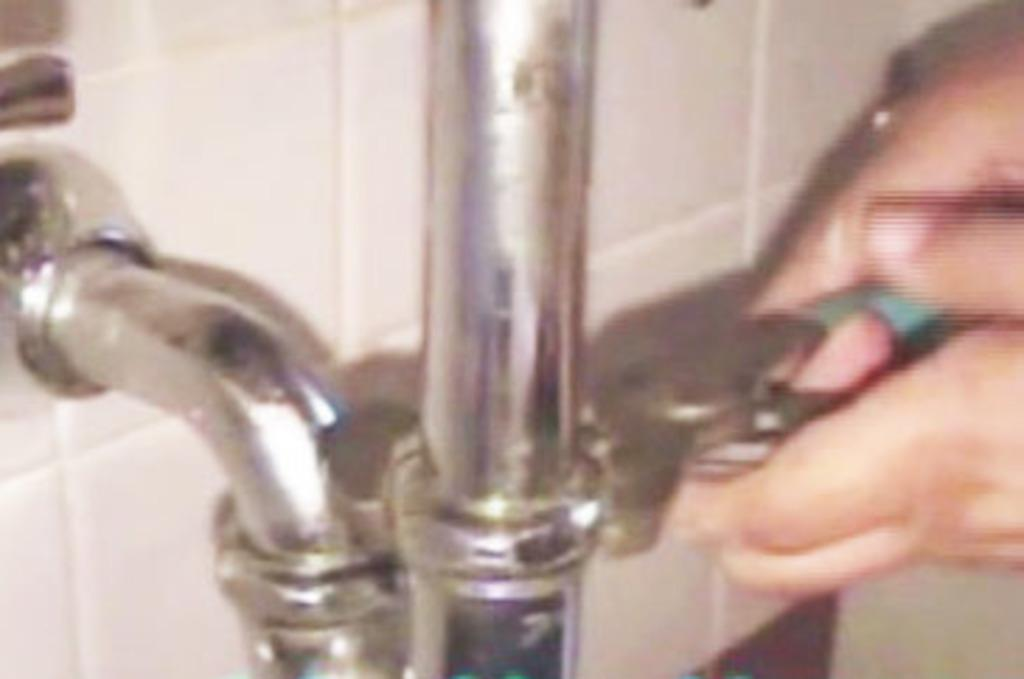What part of the human body is visible in the image? There is a human hand in the image. What type of flooring is present in the image? There are tiles in the image, and they are white in color. What material is the pipe made of in the image? The pipe in the image is made of steel. What type of flowers can be seen growing on the steel pipe in the image? There are no flowers present in the image, and the steel pipe is not depicted as having any growth on it. 